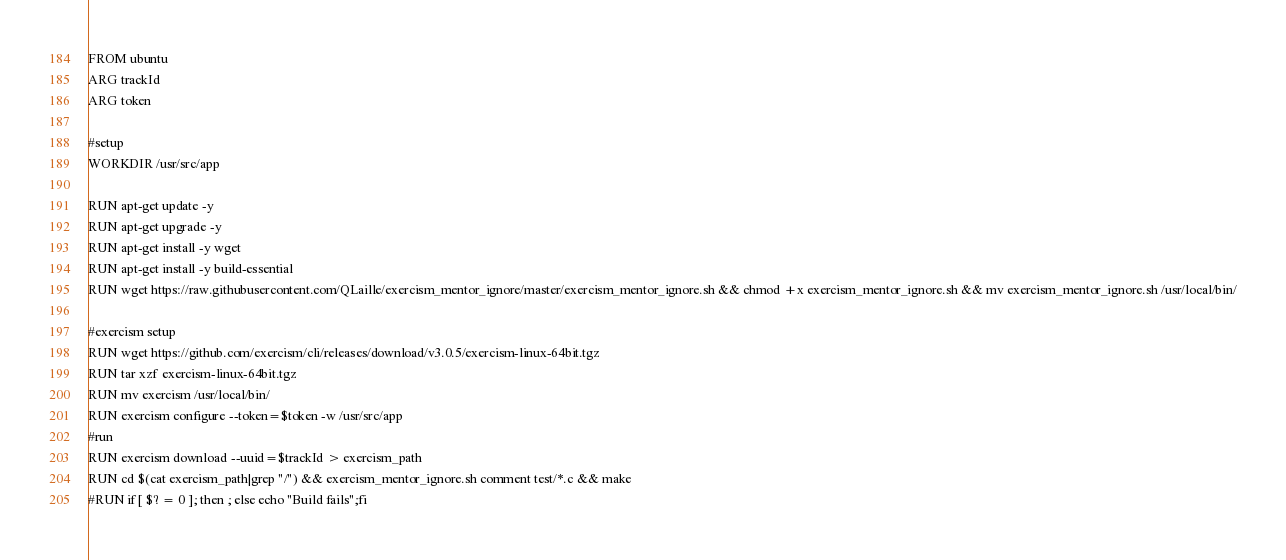Convert code to text. <code><loc_0><loc_0><loc_500><loc_500><_Dockerfile_>FROM ubuntu
ARG trackId
ARG token

#setup
WORKDIR /usr/src/app

RUN apt-get update -y
RUN apt-get upgrade -y
RUN apt-get install -y wget
RUN apt-get install -y build-essential
RUN wget https://raw.githubusercontent.com/QLaille/exercism_mentor_ignore/master/exercism_mentor_ignore.sh && chmod +x exercism_mentor_ignore.sh && mv exercism_mentor_ignore.sh /usr/local/bin/

#exercism setup
RUN wget https://github.com/exercism/cli/releases/download/v3.0.5/exercism-linux-64bit.tgz
RUN tar xzf exercism-linux-64bit.tgz
RUN mv exercism /usr/local/bin/
RUN exercism configure --token=$token -w /usr/src/app
#run
RUN exercism download --uuid=$trackId > exercism_path
RUN cd $(cat exercism_path|grep "/") && exercism_mentor_ignore.sh comment test/*.c && make
#RUN if [ $? = 0 ]; then ; else echo "Build fails";fi</code> 